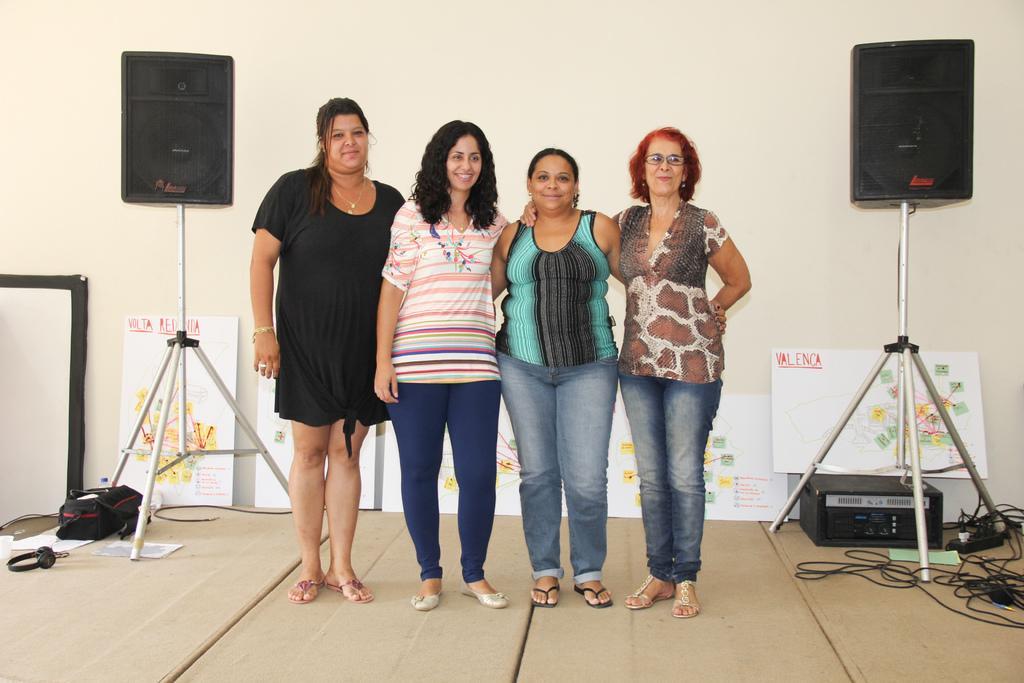How would you summarize this image in a sentence or two? In this image we can see a few people standing and posing for a photo and there are two speakers and we can see some boards with the text and pictures. There are some objects on the floor and we can see the wall. 